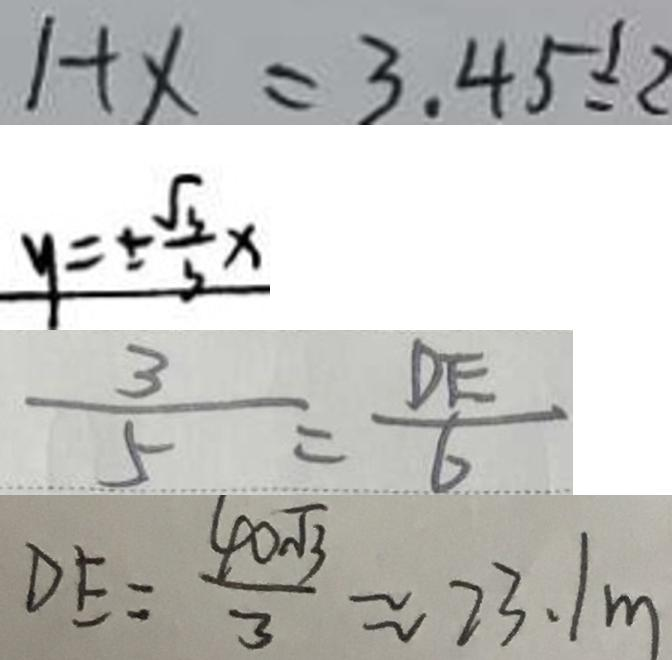Convert formula to latex. <formula><loc_0><loc_0><loc_500><loc_500>1 + x = 3 , 4 5 \div 2 
 y = \pm \frac { \sqrt { 3 } } { 3 } x 
 \frac { 3 } { 5 } = \frac { D E } { 6 } 
 D E = \frac { 4 0 \sqrt { 3 } } { 3 } \approx 2 3 . 1 m</formula> 